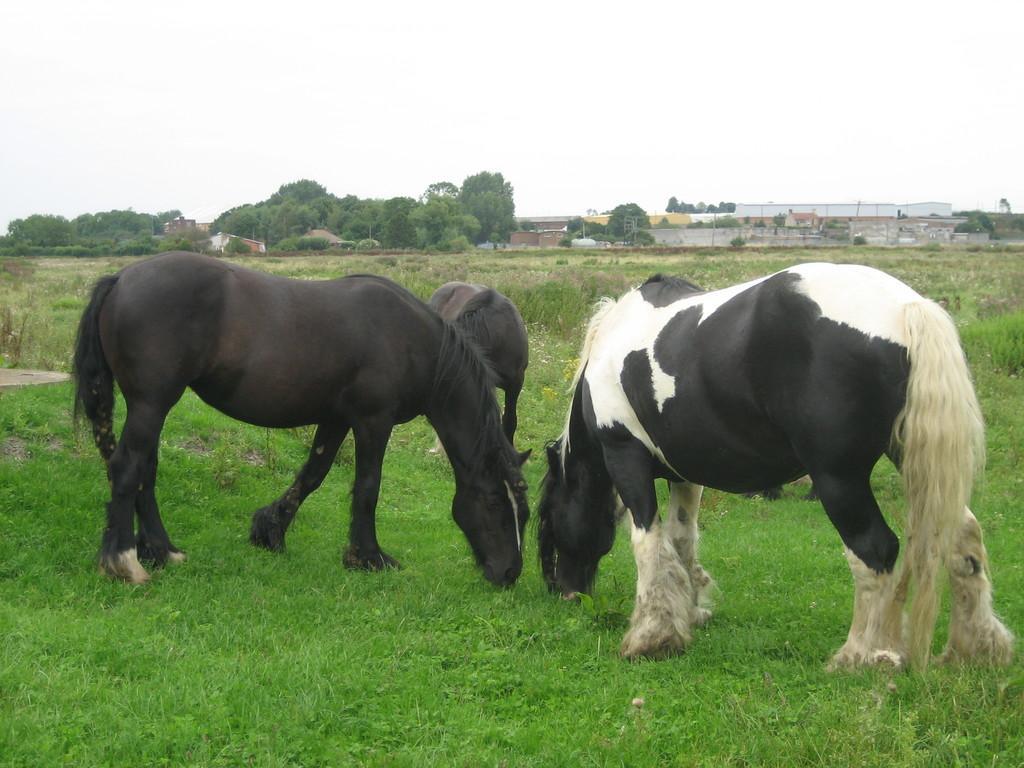Please provide a concise description of this image. In this image in the foreground there are three horses, and in the background there are some trees and buildings. At the bottom there is grass and at the top there is sky. 